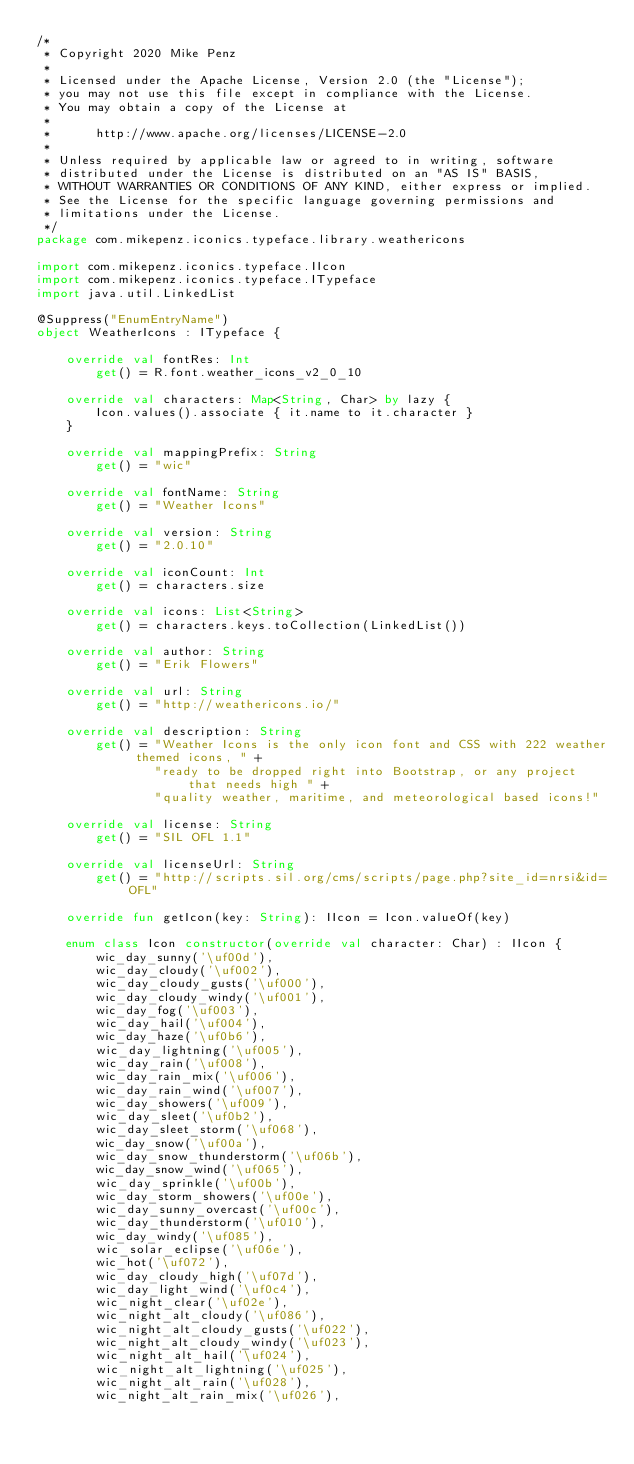<code> <loc_0><loc_0><loc_500><loc_500><_Kotlin_>/*
 * Copyright 2020 Mike Penz
 *
 * Licensed under the Apache License, Version 2.0 (the "License");
 * you may not use this file except in compliance with the License.
 * You may obtain a copy of the License at
 *
 *      http://www.apache.org/licenses/LICENSE-2.0
 *
 * Unless required by applicable law or agreed to in writing, software
 * distributed under the License is distributed on an "AS IS" BASIS,
 * WITHOUT WARRANTIES OR CONDITIONS OF ANY KIND, either express or implied.
 * See the License for the specific language governing permissions and
 * limitations under the License.
 */
package com.mikepenz.iconics.typeface.library.weathericons

import com.mikepenz.iconics.typeface.IIcon
import com.mikepenz.iconics.typeface.ITypeface
import java.util.LinkedList

@Suppress("EnumEntryName")
object WeatherIcons : ITypeface {

    override val fontRes: Int
        get() = R.font.weather_icons_v2_0_10

    override val characters: Map<String, Char> by lazy {
        Icon.values().associate { it.name to it.character }
    }

    override val mappingPrefix: String
        get() = "wic"

    override val fontName: String
        get() = "Weather Icons"

    override val version: String
        get() = "2.0.10"

    override val iconCount: Int
        get() = characters.size

    override val icons: List<String>
        get() = characters.keys.toCollection(LinkedList())

    override val author: String
        get() = "Erik Flowers"

    override val url: String
        get() = "http://weathericons.io/"

    override val description: String
        get() = "Weather Icons is the only icon font and CSS with 222 weather themed icons, " +
                "ready to be dropped right into Bootstrap, or any project that needs high " +
                "quality weather, maritime, and meteorological based icons!"

    override val license: String
        get() = "SIL OFL 1.1"

    override val licenseUrl: String
        get() = "http://scripts.sil.org/cms/scripts/page.php?site_id=nrsi&id=OFL"

    override fun getIcon(key: String): IIcon = Icon.valueOf(key)

    enum class Icon constructor(override val character: Char) : IIcon {
        wic_day_sunny('\uf00d'),
        wic_day_cloudy('\uf002'),
        wic_day_cloudy_gusts('\uf000'),
        wic_day_cloudy_windy('\uf001'),
        wic_day_fog('\uf003'),
        wic_day_hail('\uf004'),
        wic_day_haze('\uf0b6'),
        wic_day_lightning('\uf005'),
        wic_day_rain('\uf008'),
        wic_day_rain_mix('\uf006'),
        wic_day_rain_wind('\uf007'),
        wic_day_showers('\uf009'),
        wic_day_sleet('\uf0b2'),
        wic_day_sleet_storm('\uf068'),
        wic_day_snow('\uf00a'),
        wic_day_snow_thunderstorm('\uf06b'),
        wic_day_snow_wind('\uf065'),
        wic_day_sprinkle('\uf00b'),
        wic_day_storm_showers('\uf00e'),
        wic_day_sunny_overcast('\uf00c'),
        wic_day_thunderstorm('\uf010'),
        wic_day_windy('\uf085'),
        wic_solar_eclipse('\uf06e'),
        wic_hot('\uf072'),
        wic_day_cloudy_high('\uf07d'),
        wic_day_light_wind('\uf0c4'),
        wic_night_clear('\uf02e'),
        wic_night_alt_cloudy('\uf086'),
        wic_night_alt_cloudy_gusts('\uf022'),
        wic_night_alt_cloudy_windy('\uf023'),
        wic_night_alt_hail('\uf024'),
        wic_night_alt_lightning('\uf025'),
        wic_night_alt_rain('\uf028'),
        wic_night_alt_rain_mix('\uf026'),</code> 